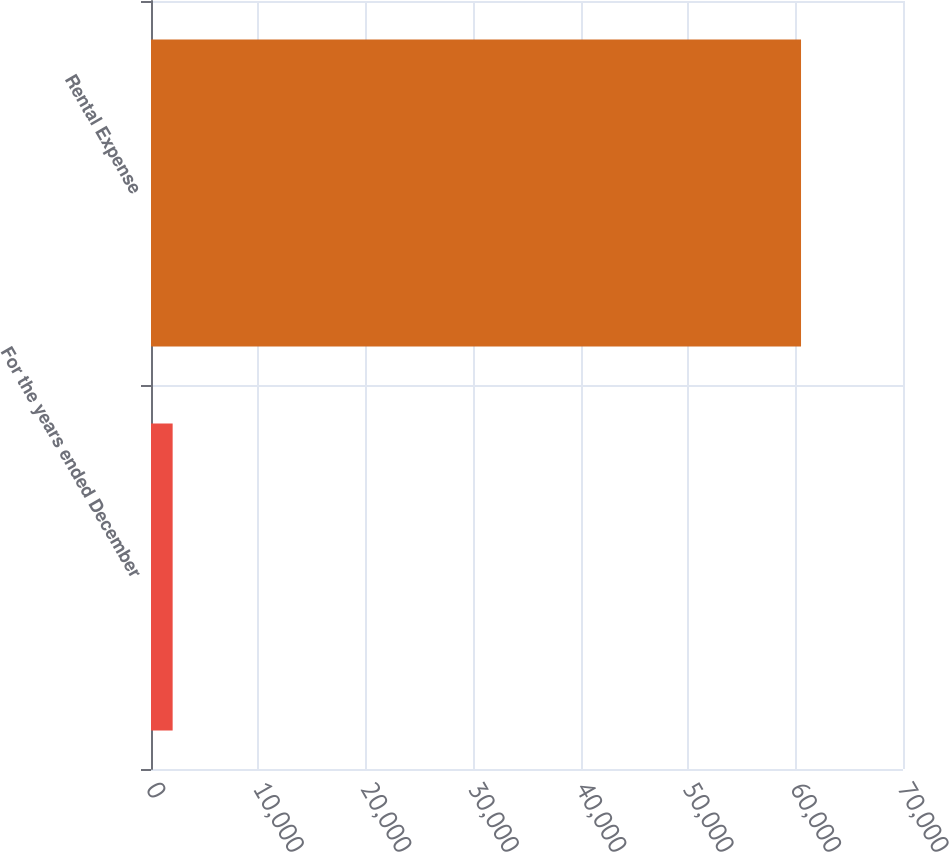Convert chart. <chart><loc_0><loc_0><loc_500><loc_500><bar_chart><fcel>For the years ended December<fcel>Rental Expense<nl><fcel>2015<fcel>60508<nl></chart> 